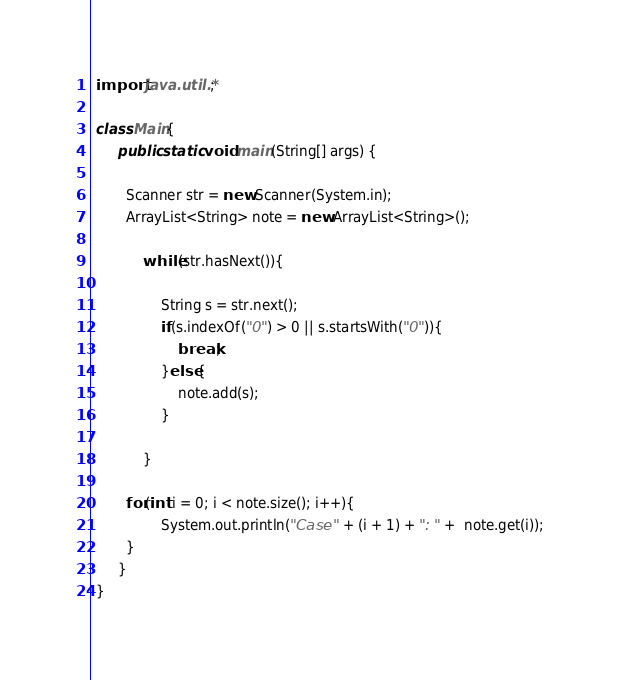<code> <loc_0><loc_0><loc_500><loc_500><_Java_> import java.util.*;
 
 class Main{
 	  public static void main(String[] args) {
 	  	
 	  	Scanner str = new Scanner(System.in);
 	  	ArrayList<String> note = new ArrayList<String>();
 	  	
	 	  	while(str.hasNext()){
	 	  		
	 	  		String s = str.next();
	 	  		if(s.indexOf("0") > 0 || s.startsWith("0")){
	 	  			break;
	 	  		}else{
	 	  			note.add(s);
	 	  		}
	 	  		
	 	  	}
 	  	
 	  	for(int i = 0; i < note.size(); i++){
 	  			System.out.println("Case " + (i + 1) + ": " +  note.get(i));
 	  	}
 	  }
 }</code> 